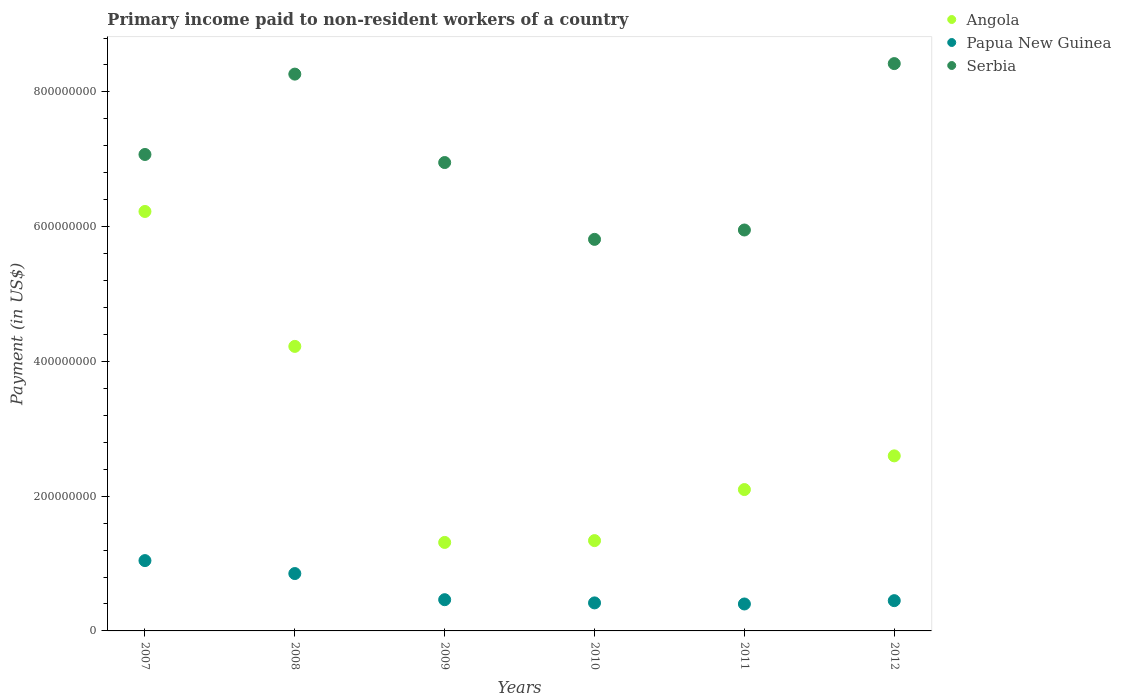How many different coloured dotlines are there?
Give a very brief answer. 3. Is the number of dotlines equal to the number of legend labels?
Your response must be concise. Yes. What is the amount paid to workers in Papua New Guinea in 2010?
Your response must be concise. 4.16e+07. Across all years, what is the maximum amount paid to workers in Papua New Guinea?
Provide a short and direct response. 1.04e+08. Across all years, what is the minimum amount paid to workers in Angola?
Keep it short and to the point. 1.31e+08. What is the total amount paid to workers in Angola in the graph?
Offer a terse response. 1.78e+09. What is the difference between the amount paid to workers in Papua New Guinea in 2008 and that in 2009?
Provide a succinct answer. 3.88e+07. What is the difference between the amount paid to workers in Serbia in 2011 and the amount paid to workers in Angola in 2007?
Ensure brevity in your answer.  -2.75e+07. What is the average amount paid to workers in Papua New Guinea per year?
Ensure brevity in your answer.  6.04e+07. In the year 2008, what is the difference between the amount paid to workers in Angola and amount paid to workers in Serbia?
Your response must be concise. -4.04e+08. What is the ratio of the amount paid to workers in Angola in 2007 to that in 2012?
Provide a short and direct response. 2.4. What is the difference between the highest and the second highest amount paid to workers in Angola?
Your answer should be compact. 2.00e+08. What is the difference between the highest and the lowest amount paid to workers in Angola?
Offer a very short reply. 4.91e+08. Is the sum of the amount paid to workers in Serbia in 2008 and 2012 greater than the maximum amount paid to workers in Papua New Guinea across all years?
Keep it short and to the point. Yes. Is the amount paid to workers in Papua New Guinea strictly greater than the amount paid to workers in Angola over the years?
Your answer should be very brief. No. Is the amount paid to workers in Papua New Guinea strictly less than the amount paid to workers in Angola over the years?
Make the answer very short. Yes. How many dotlines are there?
Your answer should be compact. 3. What is the difference between two consecutive major ticks on the Y-axis?
Ensure brevity in your answer.  2.00e+08. Where does the legend appear in the graph?
Give a very brief answer. Top right. How are the legend labels stacked?
Offer a very short reply. Vertical. What is the title of the graph?
Ensure brevity in your answer.  Primary income paid to non-resident workers of a country. Does "Germany" appear as one of the legend labels in the graph?
Your response must be concise. No. What is the label or title of the Y-axis?
Offer a very short reply. Payment (in US$). What is the Payment (in US$) of Angola in 2007?
Offer a very short reply. 6.23e+08. What is the Payment (in US$) of Papua New Guinea in 2007?
Your answer should be very brief. 1.04e+08. What is the Payment (in US$) in Serbia in 2007?
Make the answer very short. 7.07e+08. What is the Payment (in US$) in Angola in 2008?
Offer a very short reply. 4.22e+08. What is the Payment (in US$) of Papua New Guinea in 2008?
Ensure brevity in your answer.  8.51e+07. What is the Payment (in US$) of Serbia in 2008?
Your answer should be very brief. 8.26e+08. What is the Payment (in US$) in Angola in 2009?
Offer a terse response. 1.31e+08. What is the Payment (in US$) in Papua New Guinea in 2009?
Make the answer very short. 4.63e+07. What is the Payment (in US$) in Serbia in 2009?
Your response must be concise. 6.95e+08. What is the Payment (in US$) of Angola in 2010?
Provide a short and direct response. 1.34e+08. What is the Payment (in US$) of Papua New Guinea in 2010?
Provide a short and direct response. 4.16e+07. What is the Payment (in US$) in Serbia in 2010?
Provide a short and direct response. 5.81e+08. What is the Payment (in US$) of Angola in 2011?
Keep it short and to the point. 2.10e+08. What is the Payment (in US$) of Papua New Guinea in 2011?
Ensure brevity in your answer.  4.00e+07. What is the Payment (in US$) of Serbia in 2011?
Provide a succinct answer. 5.95e+08. What is the Payment (in US$) in Angola in 2012?
Keep it short and to the point. 2.60e+08. What is the Payment (in US$) of Papua New Guinea in 2012?
Give a very brief answer. 4.49e+07. What is the Payment (in US$) of Serbia in 2012?
Make the answer very short. 8.42e+08. Across all years, what is the maximum Payment (in US$) of Angola?
Make the answer very short. 6.23e+08. Across all years, what is the maximum Payment (in US$) in Papua New Guinea?
Your answer should be very brief. 1.04e+08. Across all years, what is the maximum Payment (in US$) in Serbia?
Your answer should be very brief. 8.42e+08. Across all years, what is the minimum Payment (in US$) of Angola?
Make the answer very short. 1.31e+08. Across all years, what is the minimum Payment (in US$) in Papua New Guinea?
Your response must be concise. 4.00e+07. Across all years, what is the minimum Payment (in US$) in Serbia?
Keep it short and to the point. 5.81e+08. What is the total Payment (in US$) in Angola in the graph?
Give a very brief answer. 1.78e+09. What is the total Payment (in US$) in Papua New Guinea in the graph?
Your answer should be very brief. 3.62e+08. What is the total Payment (in US$) in Serbia in the graph?
Ensure brevity in your answer.  4.25e+09. What is the difference between the Payment (in US$) of Angola in 2007 and that in 2008?
Your response must be concise. 2.00e+08. What is the difference between the Payment (in US$) of Papua New Guinea in 2007 and that in 2008?
Keep it short and to the point. 1.92e+07. What is the difference between the Payment (in US$) of Serbia in 2007 and that in 2008?
Give a very brief answer. -1.19e+08. What is the difference between the Payment (in US$) of Angola in 2007 and that in 2009?
Provide a succinct answer. 4.91e+08. What is the difference between the Payment (in US$) of Papua New Guinea in 2007 and that in 2009?
Offer a very short reply. 5.80e+07. What is the difference between the Payment (in US$) in Serbia in 2007 and that in 2009?
Give a very brief answer. 1.20e+07. What is the difference between the Payment (in US$) of Angola in 2007 and that in 2010?
Give a very brief answer. 4.89e+08. What is the difference between the Payment (in US$) of Papua New Guinea in 2007 and that in 2010?
Your response must be concise. 6.28e+07. What is the difference between the Payment (in US$) in Serbia in 2007 and that in 2010?
Make the answer very short. 1.26e+08. What is the difference between the Payment (in US$) in Angola in 2007 and that in 2011?
Your answer should be very brief. 4.13e+08. What is the difference between the Payment (in US$) in Papua New Guinea in 2007 and that in 2011?
Your response must be concise. 6.44e+07. What is the difference between the Payment (in US$) in Serbia in 2007 and that in 2011?
Offer a terse response. 1.12e+08. What is the difference between the Payment (in US$) in Angola in 2007 and that in 2012?
Your answer should be very brief. 3.63e+08. What is the difference between the Payment (in US$) of Papua New Guinea in 2007 and that in 2012?
Provide a succinct answer. 5.95e+07. What is the difference between the Payment (in US$) in Serbia in 2007 and that in 2012?
Your answer should be very brief. -1.35e+08. What is the difference between the Payment (in US$) of Angola in 2008 and that in 2009?
Offer a terse response. 2.91e+08. What is the difference between the Payment (in US$) in Papua New Guinea in 2008 and that in 2009?
Provide a succinct answer. 3.88e+07. What is the difference between the Payment (in US$) in Serbia in 2008 and that in 2009?
Give a very brief answer. 1.31e+08. What is the difference between the Payment (in US$) in Angola in 2008 and that in 2010?
Provide a succinct answer. 2.88e+08. What is the difference between the Payment (in US$) in Papua New Guinea in 2008 and that in 2010?
Your response must be concise. 4.36e+07. What is the difference between the Payment (in US$) in Serbia in 2008 and that in 2010?
Offer a terse response. 2.45e+08. What is the difference between the Payment (in US$) of Angola in 2008 and that in 2011?
Your answer should be compact. 2.12e+08. What is the difference between the Payment (in US$) of Papua New Guinea in 2008 and that in 2011?
Offer a terse response. 4.52e+07. What is the difference between the Payment (in US$) in Serbia in 2008 and that in 2011?
Your response must be concise. 2.31e+08. What is the difference between the Payment (in US$) of Angola in 2008 and that in 2012?
Make the answer very short. 1.62e+08. What is the difference between the Payment (in US$) of Papua New Guinea in 2008 and that in 2012?
Your answer should be very brief. 4.02e+07. What is the difference between the Payment (in US$) in Serbia in 2008 and that in 2012?
Ensure brevity in your answer.  -1.56e+07. What is the difference between the Payment (in US$) of Angola in 2009 and that in 2010?
Provide a short and direct response. -2.70e+06. What is the difference between the Payment (in US$) of Papua New Guinea in 2009 and that in 2010?
Your response must be concise. 4.76e+06. What is the difference between the Payment (in US$) in Serbia in 2009 and that in 2010?
Give a very brief answer. 1.14e+08. What is the difference between the Payment (in US$) in Angola in 2009 and that in 2011?
Give a very brief answer. -7.85e+07. What is the difference between the Payment (in US$) in Papua New Guinea in 2009 and that in 2011?
Give a very brief answer. 6.37e+06. What is the difference between the Payment (in US$) of Serbia in 2009 and that in 2011?
Provide a succinct answer. 1.00e+08. What is the difference between the Payment (in US$) in Angola in 2009 and that in 2012?
Keep it short and to the point. -1.28e+08. What is the difference between the Payment (in US$) of Papua New Guinea in 2009 and that in 2012?
Make the answer very short. 1.43e+06. What is the difference between the Payment (in US$) in Serbia in 2009 and that in 2012?
Ensure brevity in your answer.  -1.47e+08. What is the difference between the Payment (in US$) in Angola in 2010 and that in 2011?
Your response must be concise. -7.58e+07. What is the difference between the Payment (in US$) in Papua New Guinea in 2010 and that in 2011?
Provide a short and direct response. 1.61e+06. What is the difference between the Payment (in US$) in Serbia in 2010 and that in 2011?
Keep it short and to the point. -1.39e+07. What is the difference between the Payment (in US$) of Angola in 2010 and that in 2012?
Provide a succinct answer. -1.26e+08. What is the difference between the Payment (in US$) of Papua New Guinea in 2010 and that in 2012?
Offer a very short reply. -3.33e+06. What is the difference between the Payment (in US$) in Serbia in 2010 and that in 2012?
Your answer should be very brief. -2.61e+08. What is the difference between the Payment (in US$) of Angola in 2011 and that in 2012?
Ensure brevity in your answer.  -5.00e+07. What is the difference between the Payment (in US$) in Papua New Guinea in 2011 and that in 2012?
Ensure brevity in your answer.  -4.94e+06. What is the difference between the Payment (in US$) of Serbia in 2011 and that in 2012?
Your answer should be compact. -2.47e+08. What is the difference between the Payment (in US$) in Angola in 2007 and the Payment (in US$) in Papua New Guinea in 2008?
Ensure brevity in your answer.  5.37e+08. What is the difference between the Payment (in US$) in Angola in 2007 and the Payment (in US$) in Serbia in 2008?
Keep it short and to the point. -2.04e+08. What is the difference between the Payment (in US$) in Papua New Guinea in 2007 and the Payment (in US$) in Serbia in 2008?
Offer a very short reply. -7.22e+08. What is the difference between the Payment (in US$) in Angola in 2007 and the Payment (in US$) in Papua New Guinea in 2009?
Provide a succinct answer. 5.76e+08. What is the difference between the Payment (in US$) of Angola in 2007 and the Payment (in US$) of Serbia in 2009?
Offer a very short reply. -7.26e+07. What is the difference between the Payment (in US$) of Papua New Guinea in 2007 and the Payment (in US$) of Serbia in 2009?
Offer a very short reply. -5.91e+08. What is the difference between the Payment (in US$) in Angola in 2007 and the Payment (in US$) in Papua New Guinea in 2010?
Your answer should be very brief. 5.81e+08. What is the difference between the Payment (in US$) in Angola in 2007 and the Payment (in US$) in Serbia in 2010?
Your response must be concise. 4.14e+07. What is the difference between the Payment (in US$) in Papua New Guinea in 2007 and the Payment (in US$) in Serbia in 2010?
Ensure brevity in your answer.  -4.77e+08. What is the difference between the Payment (in US$) in Angola in 2007 and the Payment (in US$) in Papua New Guinea in 2011?
Make the answer very short. 5.83e+08. What is the difference between the Payment (in US$) in Angola in 2007 and the Payment (in US$) in Serbia in 2011?
Your answer should be very brief. 2.75e+07. What is the difference between the Payment (in US$) in Papua New Guinea in 2007 and the Payment (in US$) in Serbia in 2011?
Provide a short and direct response. -4.91e+08. What is the difference between the Payment (in US$) in Angola in 2007 and the Payment (in US$) in Papua New Guinea in 2012?
Ensure brevity in your answer.  5.78e+08. What is the difference between the Payment (in US$) in Angola in 2007 and the Payment (in US$) in Serbia in 2012?
Your answer should be compact. -2.19e+08. What is the difference between the Payment (in US$) in Papua New Guinea in 2007 and the Payment (in US$) in Serbia in 2012?
Give a very brief answer. -7.38e+08. What is the difference between the Payment (in US$) of Angola in 2008 and the Payment (in US$) of Papua New Guinea in 2009?
Your answer should be compact. 3.76e+08. What is the difference between the Payment (in US$) in Angola in 2008 and the Payment (in US$) in Serbia in 2009?
Your answer should be compact. -2.73e+08. What is the difference between the Payment (in US$) in Papua New Guinea in 2008 and the Payment (in US$) in Serbia in 2009?
Your response must be concise. -6.10e+08. What is the difference between the Payment (in US$) in Angola in 2008 and the Payment (in US$) in Papua New Guinea in 2010?
Give a very brief answer. 3.81e+08. What is the difference between the Payment (in US$) of Angola in 2008 and the Payment (in US$) of Serbia in 2010?
Your answer should be very brief. -1.59e+08. What is the difference between the Payment (in US$) of Papua New Guinea in 2008 and the Payment (in US$) of Serbia in 2010?
Provide a succinct answer. -4.96e+08. What is the difference between the Payment (in US$) in Angola in 2008 and the Payment (in US$) in Papua New Guinea in 2011?
Keep it short and to the point. 3.82e+08. What is the difference between the Payment (in US$) of Angola in 2008 and the Payment (in US$) of Serbia in 2011?
Your answer should be very brief. -1.73e+08. What is the difference between the Payment (in US$) of Papua New Guinea in 2008 and the Payment (in US$) of Serbia in 2011?
Keep it short and to the point. -5.10e+08. What is the difference between the Payment (in US$) in Angola in 2008 and the Payment (in US$) in Papua New Guinea in 2012?
Offer a terse response. 3.77e+08. What is the difference between the Payment (in US$) in Angola in 2008 and the Payment (in US$) in Serbia in 2012?
Your answer should be very brief. -4.20e+08. What is the difference between the Payment (in US$) of Papua New Guinea in 2008 and the Payment (in US$) of Serbia in 2012?
Offer a terse response. -7.57e+08. What is the difference between the Payment (in US$) of Angola in 2009 and the Payment (in US$) of Papua New Guinea in 2010?
Provide a succinct answer. 8.97e+07. What is the difference between the Payment (in US$) in Angola in 2009 and the Payment (in US$) in Serbia in 2010?
Provide a succinct answer. -4.50e+08. What is the difference between the Payment (in US$) of Papua New Guinea in 2009 and the Payment (in US$) of Serbia in 2010?
Make the answer very short. -5.35e+08. What is the difference between the Payment (in US$) of Angola in 2009 and the Payment (in US$) of Papua New Guinea in 2011?
Make the answer very short. 9.13e+07. What is the difference between the Payment (in US$) in Angola in 2009 and the Payment (in US$) in Serbia in 2011?
Ensure brevity in your answer.  -4.64e+08. What is the difference between the Payment (in US$) in Papua New Guinea in 2009 and the Payment (in US$) in Serbia in 2011?
Offer a terse response. -5.49e+08. What is the difference between the Payment (in US$) of Angola in 2009 and the Payment (in US$) of Papua New Guinea in 2012?
Offer a terse response. 8.64e+07. What is the difference between the Payment (in US$) of Angola in 2009 and the Payment (in US$) of Serbia in 2012?
Give a very brief answer. -7.11e+08. What is the difference between the Payment (in US$) in Papua New Guinea in 2009 and the Payment (in US$) in Serbia in 2012?
Provide a short and direct response. -7.96e+08. What is the difference between the Payment (in US$) in Angola in 2010 and the Payment (in US$) in Papua New Guinea in 2011?
Provide a short and direct response. 9.41e+07. What is the difference between the Payment (in US$) in Angola in 2010 and the Payment (in US$) in Serbia in 2011?
Ensure brevity in your answer.  -4.61e+08. What is the difference between the Payment (in US$) of Papua New Guinea in 2010 and the Payment (in US$) of Serbia in 2011?
Provide a short and direct response. -5.53e+08. What is the difference between the Payment (in US$) of Angola in 2010 and the Payment (in US$) of Papua New Guinea in 2012?
Offer a very short reply. 8.91e+07. What is the difference between the Payment (in US$) in Angola in 2010 and the Payment (in US$) in Serbia in 2012?
Keep it short and to the point. -7.08e+08. What is the difference between the Payment (in US$) of Papua New Guinea in 2010 and the Payment (in US$) of Serbia in 2012?
Give a very brief answer. -8.00e+08. What is the difference between the Payment (in US$) of Angola in 2011 and the Payment (in US$) of Papua New Guinea in 2012?
Your answer should be compact. 1.65e+08. What is the difference between the Payment (in US$) in Angola in 2011 and the Payment (in US$) in Serbia in 2012?
Make the answer very short. -6.32e+08. What is the difference between the Payment (in US$) of Papua New Guinea in 2011 and the Payment (in US$) of Serbia in 2012?
Ensure brevity in your answer.  -8.02e+08. What is the average Payment (in US$) in Angola per year?
Your answer should be compact. 2.97e+08. What is the average Payment (in US$) of Papua New Guinea per year?
Give a very brief answer. 6.04e+07. What is the average Payment (in US$) in Serbia per year?
Make the answer very short. 7.08e+08. In the year 2007, what is the difference between the Payment (in US$) in Angola and Payment (in US$) in Papua New Guinea?
Make the answer very short. 5.18e+08. In the year 2007, what is the difference between the Payment (in US$) of Angola and Payment (in US$) of Serbia?
Your answer should be compact. -8.46e+07. In the year 2007, what is the difference between the Payment (in US$) in Papua New Guinea and Payment (in US$) in Serbia?
Your answer should be compact. -6.03e+08. In the year 2008, what is the difference between the Payment (in US$) of Angola and Payment (in US$) of Papua New Guinea?
Your response must be concise. 3.37e+08. In the year 2008, what is the difference between the Payment (in US$) in Angola and Payment (in US$) in Serbia?
Your response must be concise. -4.04e+08. In the year 2008, what is the difference between the Payment (in US$) in Papua New Guinea and Payment (in US$) in Serbia?
Give a very brief answer. -7.41e+08. In the year 2009, what is the difference between the Payment (in US$) of Angola and Payment (in US$) of Papua New Guinea?
Give a very brief answer. 8.50e+07. In the year 2009, what is the difference between the Payment (in US$) of Angola and Payment (in US$) of Serbia?
Provide a succinct answer. -5.64e+08. In the year 2009, what is the difference between the Payment (in US$) of Papua New Guinea and Payment (in US$) of Serbia?
Your answer should be very brief. -6.49e+08. In the year 2010, what is the difference between the Payment (in US$) in Angola and Payment (in US$) in Papua New Guinea?
Your answer should be compact. 9.24e+07. In the year 2010, what is the difference between the Payment (in US$) of Angola and Payment (in US$) of Serbia?
Provide a short and direct response. -4.47e+08. In the year 2010, what is the difference between the Payment (in US$) of Papua New Guinea and Payment (in US$) of Serbia?
Your answer should be compact. -5.40e+08. In the year 2011, what is the difference between the Payment (in US$) of Angola and Payment (in US$) of Papua New Guinea?
Give a very brief answer. 1.70e+08. In the year 2011, what is the difference between the Payment (in US$) of Angola and Payment (in US$) of Serbia?
Provide a succinct answer. -3.85e+08. In the year 2011, what is the difference between the Payment (in US$) in Papua New Guinea and Payment (in US$) in Serbia?
Provide a short and direct response. -5.55e+08. In the year 2012, what is the difference between the Payment (in US$) of Angola and Payment (in US$) of Papua New Guinea?
Offer a terse response. 2.15e+08. In the year 2012, what is the difference between the Payment (in US$) of Angola and Payment (in US$) of Serbia?
Your response must be concise. -5.82e+08. In the year 2012, what is the difference between the Payment (in US$) in Papua New Guinea and Payment (in US$) in Serbia?
Provide a short and direct response. -7.97e+08. What is the ratio of the Payment (in US$) in Angola in 2007 to that in 2008?
Offer a very short reply. 1.47. What is the ratio of the Payment (in US$) of Papua New Guinea in 2007 to that in 2008?
Make the answer very short. 1.23. What is the ratio of the Payment (in US$) of Serbia in 2007 to that in 2008?
Offer a terse response. 0.86. What is the ratio of the Payment (in US$) of Angola in 2007 to that in 2009?
Offer a terse response. 4.74. What is the ratio of the Payment (in US$) in Papua New Guinea in 2007 to that in 2009?
Ensure brevity in your answer.  2.25. What is the ratio of the Payment (in US$) of Serbia in 2007 to that in 2009?
Offer a very short reply. 1.02. What is the ratio of the Payment (in US$) of Angola in 2007 to that in 2010?
Offer a terse response. 4.64. What is the ratio of the Payment (in US$) of Papua New Guinea in 2007 to that in 2010?
Provide a short and direct response. 2.51. What is the ratio of the Payment (in US$) in Serbia in 2007 to that in 2010?
Your answer should be very brief. 1.22. What is the ratio of the Payment (in US$) of Angola in 2007 to that in 2011?
Offer a terse response. 2.97. What is the ratio of the Payment (in US$) of Papua New Guinea in 2007 to that in 2011?
Make the answer very short. 2.61. What is the ratio of the Payment (in US$) in Serbia in 2007 to that in 2011?
Your response must be concise. 1.19. What is the ratio of the Payment (in US$) in Angola in 2007 to that in 2012?
Offer a terse response. 2.4. What is the ratio of the Payment (in US$) of Papua New Guinea in 2007 to that in 2012?
Provide a short and direct response. 2.32. What is the ratio of the Payment (in US$) of Serbia in 2007 to that in 2012?
Keep it short and to the point. 0.84. What is the ratio of the Payment (in US$) of Angola in 2008 to that in 2009?
Your response must be concise. 3.22. What is the ratio of the Payment (in US$) in Papua New Guinea in 2008 to that in 2009?
Give a very brief answer. 1.84. What is the ratio of the Payment (in US$) in Serbia in 2008 to that in 2009?
Give a very brief answer. 1.19. What is the ratio of the Payment (in US$) of Angola in 2008 to that in 2010?
Offer a very short reply. 3.15. What is the ratio of the Payment (in US$) of Papua New Guinea in 2008 to that in 2010?
Make the answer very short. 2.05. What is the ratio of the Payment (in US$) of Serbia in 2008 to that in 2010?
Provide a succinct answer. 1.42. What is the ratio of the Payment (in US$) of Angola in 2008 to that in 2011?
Give a very brief answer. 2.01. What is the ratio of the Payment (in US$) of Papua New Guinea in 2008 to that in 2011?
Offer a very short reply. 2.13. What is the ratio of the Payment (in US$) of Serbia in 2008 to that in 2011?
Make the answer very short. 1.39. What is the ratio of the Payment (in US$) in Angola in 2008 to that in 2012?
Give a very brief answer. 1.63. What is the ratio of the Payment (in US$) in Papua New Guinea in 2008 to that in 2012?
Your answer should be compact. 1.9. What is the ratio of the Payment (in US$) in Serbia in 2008 to that in 2012?
Make the answer very short. 0.98. What is the ratio of the Payment (in US$) of Angola in 2009 to that in 2010?
Make the answer very short. 0.98. What is the ratio of the Payment (in US$) of Papua New Guinea in 2009 to that in 2010?
Your answer should be compact. 1.11. What is the ratio of the Payment (in US$) in Serbia in 2009 to that in 2010?
Keep it short and to the point. 1.2. What is the ratio of the Payment (in US$) in Angola in 2009 to that in 2011?
Make the answer very short. 0.63. What is the ratio of the Payment (in US$) in Papua New Guinea in 2009 to that in 2011?
Your response must be concise. 1.16. What is the ratio of the Payment (in US$) in Serbia in 2009 to that in 2011?
Give a very brief answer. 1.17. What is the ratio of the Payment (in US$) in Angola in 2009 to that in 2012?
Give a very brief answer. 0.51. What is the ratio of the Payment (in US$) in Papua New Guinea in 2009 to that in 2012?
Your answer should be very brief. 1.03. What is the ratio of the Payment (in US$) in Serbia in 2009 to that in 2012?
Your answer should be very brief. 0.83. What is the ratio of the Payment (in US$) in Angola in 2010 to that in 2011?
Ensure brevity in your answer.  0.64. What is the ratio of the Payment (in US$) in Papua New Guinea in 2010 to that in 2011?
Make the answer very short. 1.04. What is the ratio of the Payment (in US$) in Serbia in 2010 to that in 2011?
Your answer should be very brief. 0.98. What is the ratio of the Payment (in US$) in Angola in 2010 to that in 2012?
Keep it short and to the point. 0.52. What is the ratio of the Payment (in US$) in Papua New Guinea in 2010 to that in 2012?
Give a very brief answer. 0.93. What is the ratio of the Payment (in US$) of Serbia in 2010 to that in 2012?
Offer a terse response. 0.69. What is the ratio of the Payment (in US$) in Angola in 2011 to that in 2012?
Your answer should be compact. 0.81. What is the ratio of the Payment (in US$) of Papua New Guinea in 2011 to that in 2012?
Your answer should be very brief. 0.89. What is the ratio of the Payment (in US$) in Serbia in 2011 to that in 2012?
Provide a succinct answer. 0.71. What is the difference between the highest and the second highest Payment (in US$) in Angola?
Your response must be concise. 2.00e+08. What is the difference between the highest and the second highest Payment (in US$) of Papua New Guinea?
Offer a very short reply. 1.92e+07. What is the difference between the highest and the second highest Payment (in US$) in Serbia?
Offer a terse response. 1.56e+07. What is the difference between the highest and the lowest Payment (in US$) in Angola?
Give a very brief answer. 4.91e+08. What is the difference between the highest and the lowest Payment (in US$) in Papua New Guinea?
Your response must be concise. 6.44e+07. What is the difference between the highest and the lowest Payment (in US$) in Serbia?
Keep it short and to the point. 2.61e+08. 